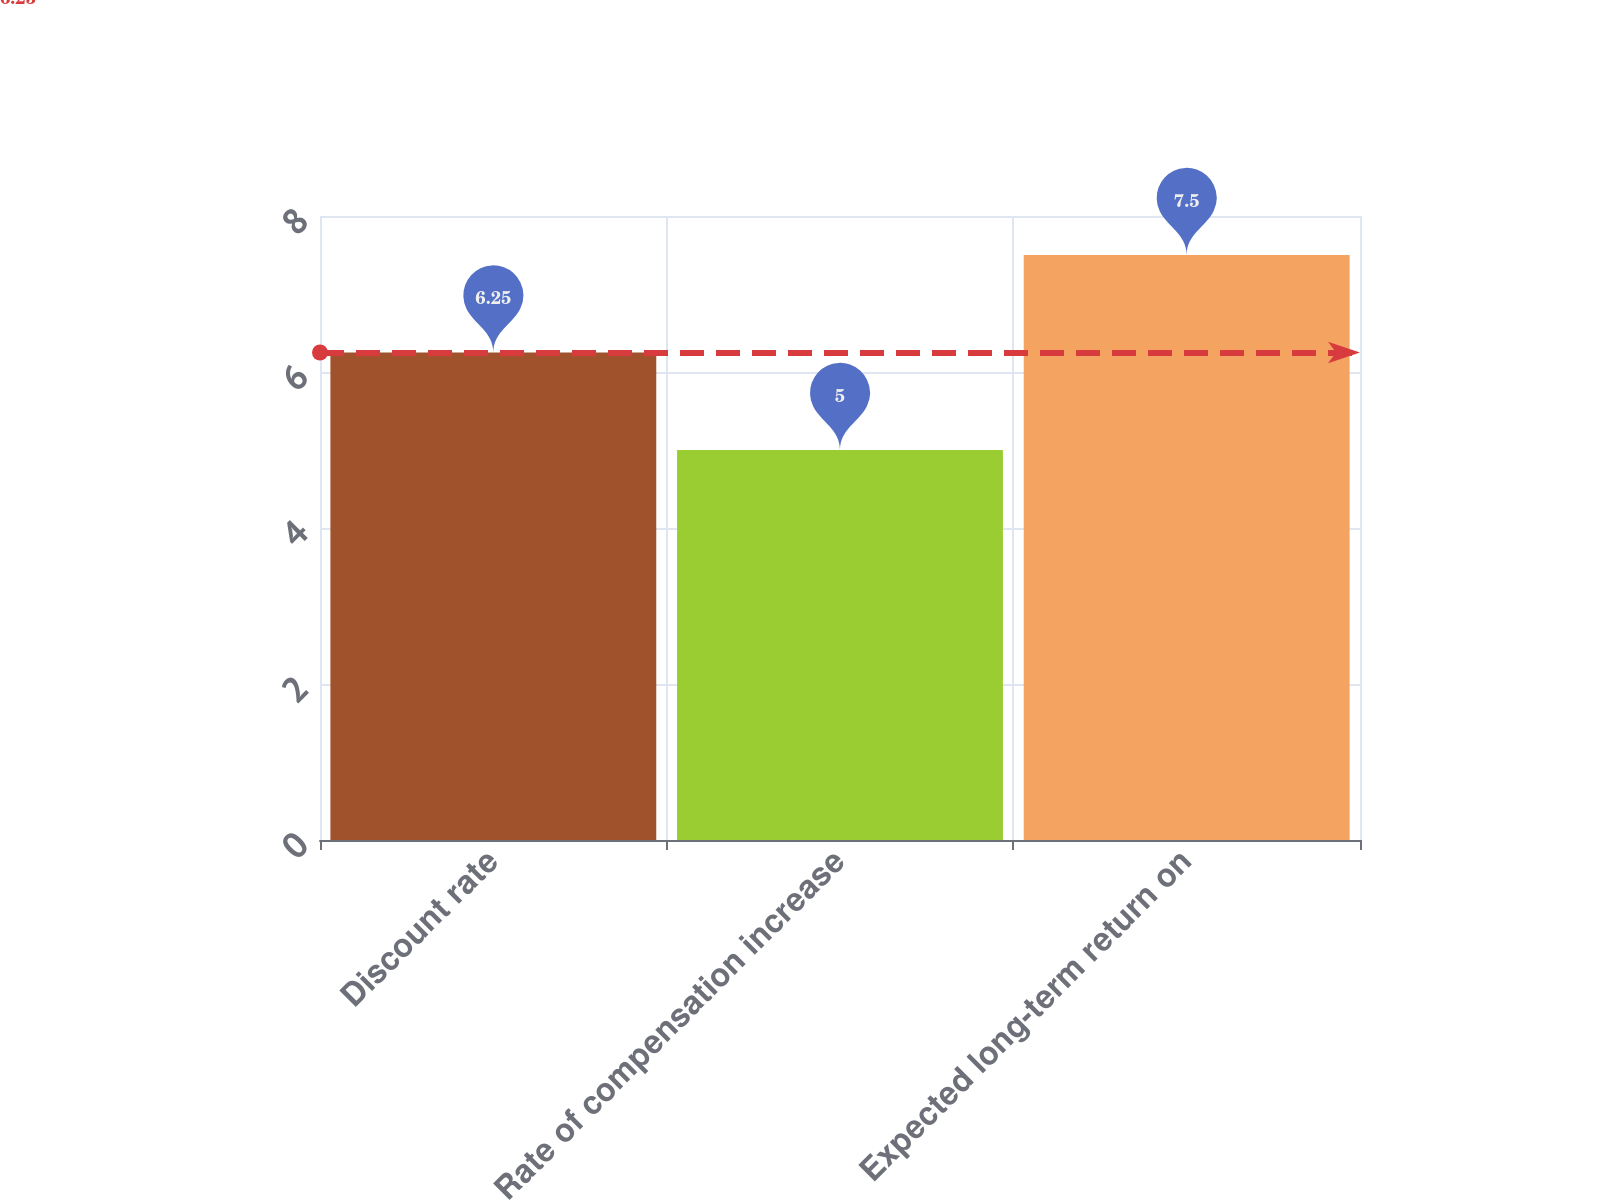<chart> <loc_0><loc_0><loc_500><loc_500><bar_chart><fcel>Discount rate<fcel>Rate of compensation increase<fcel>Expected long-term return on<nl><fcel>6.25<fcel>5<fcel>7.5<nl></chart> 